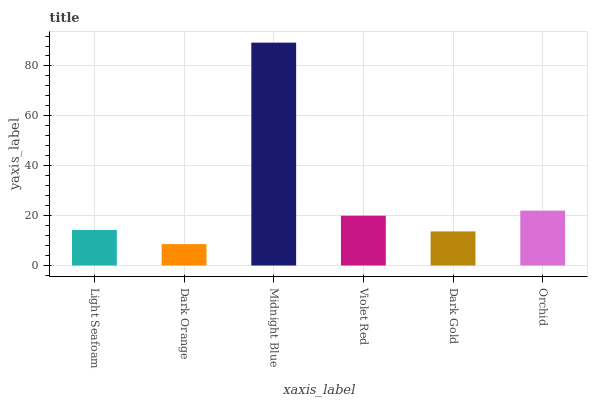Is Dark Orange the minimum?
Answer yes or no. Yes. Is Midnight Blue the maximum?
Answer yes or no. Yes. Is Midnight Blue the minimum?
Answer yes or no. No. Is Dark Orange the maximum?
Answer yes or no. No. Is Midnight Blue greater than Dark Orange?
Answer yes or no. Yes. Is Dark Orange less than Midnight Blue?
Answer yes or no. Yes. Is Dark Orange greater than Midnight Blue?
Answer yes or no. No. Is Midnight Blue less than Dark Orange?
Answer yes or no. No. Is Violet Red the high median?
Answer yes or no. Yes. Is Light Seafoam the low median?
Answer yes or no. Yes. Is Midnight Blue the high median?
Answer yes or no. No. Is Dark Gold the low median?
Answer yes or no. No. 